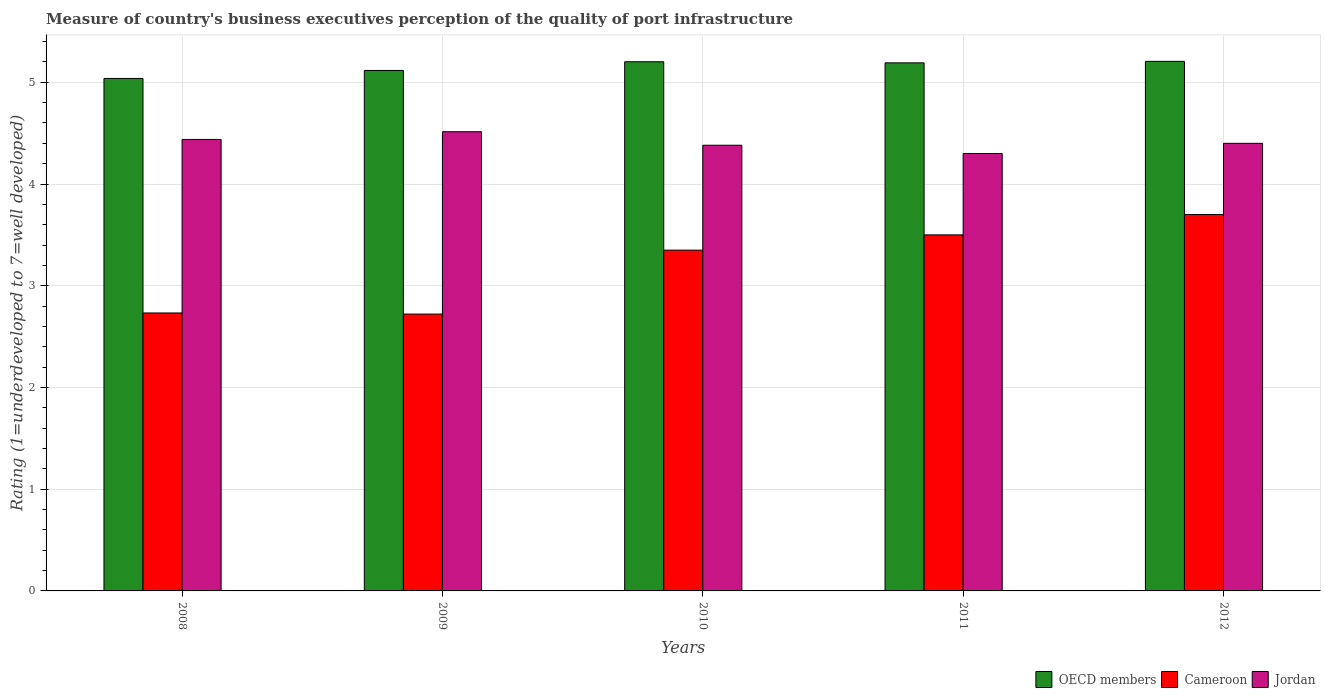How many different coloured bars are there?
Give a very brief answer. 3. Are the number of bars per tick equal to the number of legend labels?
Your answer should be very brief. Yes. What is the label of the 3rd group of bars from the left?
Your response must be concise. 2010. In how many cases, is the number of bars for a given year not equal to the number of legend labels?
Make the answer very short. 0. Across all years, what is the maximum ratings of the quality of port infrastructure in Jordan?
Keep it short and to the point. 4.51. Across all years, what is the minimum ratings of the quality of port infrastructure in Cameroon?
Ensure brevity in your answer.  2.72. In which year was the ratings of the quality of port infrastructure in Cameroon maximum?
Provide a short and direct response. 2012. What is the total ratings of the quality of port infrastructure in Jordan in the graph?
Make the answer very short. 22.03. What is the difference between the ratings of the quality of port infrastructure in Cameroon in 2009 and that in 2012?
Your response must be concise. -0.98. What is the difference between the ratings of the quality of port infrastructure in OECD members in 2008 and the ratings of the quality of port infrastructure in Cameroon in 2012?
Your answer should be very brief. 1.34. What is the average ratings of the quality of port infrastructure in Cameroon per year?
Provide a short and direct response. 3.2. In the year 2008, what is the difference between the ratings of the quality of port infrastructure in Cameroon and ratings of the quality of port infrastructure in OECD members?
Your answer should be very brief. -2.31. What is the ratio of the ratings of the quality of port infrastructure in Jordan in 2008 to that in 2009?
Ensure brevity in your answer.  0.98. What is the difference between the highest and the second highest ratings of the quality of port infrastructure in OECD members?
Keep it short and to the point. 0. What is the difference between the highest and the lowest ratings of the quality of port infrastructure in Jordan?
Your response must be concise. 0.21. In how many years, is the ratings of the quality of port infrastructure in Cameroon greater than the average ratings of the quality of port infrastructure in Cameroon taken over all years?
Offer a terse response. 3. Is the sum of the ratings of the quality of port infrastructure in Cameroon in 2010 and 2011 greater than the maximum ratings of the quality of port infrastructure in Jordan across all years?
Your answer should be compact. Yes. What does the 1st bar from the left in 2008 represents?
Offer a very short reply. OECD members. What does the 1st bar from the right in 2012 represents?
Provide a succinct answer. Jordan. How many bars are there?
Offer a terse response. 15. Are all the bars in the graph horizontal?
Keep it short and to the point. No. How many years are there in the graph?
Your response must be concise. 5. Does the graph contain any zero values?
Provide a succinct answer. No. Does the graph contain grids?
Your answer should be compact. Yes. How are the legend labels stacked?
Provide a succinct answer. Horizontal. What is the title of the graph?
Provide a short and direct response. Measure of country's business executives perception of the quality of port infrastructure. What is the label or title of the X-axis?
Offer a terse response. Years. What is the label or title of the Y-axis?
Give a very brief answer. Rating (1=underdeveloped to 7=well developed). What is the Rating (1=underdeveloped to 7=well developed) in OECD members in 2008?
Keep it short and to the point. 5.04. What is the Rating (1=underdeveloped to 7=well developed) in Cameroon in 2008?
Provide a short and direct response. 2.73. What is the Rating (1=underdeveloped to 7=well developed) in Jordan in 2008?
Provide a succinct answer. 4.44. What is the Rating (1=underdeveloped to 7=well developed) in OECD members in 2009?
Provide a succinct answer. 5.12. What is the Rating (1=underdeveloped to 7=well developed) of Cameroon in 2009?
Your answer should be very brief. 2.72. What is the Rating (1=underdeveloped to 7=well developed) of Jordan in 2009?
Ensure brevity in your answer.  4.51. What is the Rating (1=underdeveloped to 7=well developed) of OECD members in 2010?
Your answer should be compact. 5.2. What is the Rating (1=underdeveloped to 7=well developed) of Cameroon in 2010?
Your response must be concise. 3.35. What is the Rating (1=underdeveloped to 7=well developed) of Jordan in 2010?
Your answer should be compact. 4.38. What is the Rating (1=underdeveloped to 7=well developed) of OECD members in 2011?
Provide a succinct answer. 5.19. What is the Rating (1=underdeveloped to 7=well developed) in Cameroon in 2011?
Your answer should be compact. 3.5. What is the Rating (1=underdeveloped to 7=well developed) of Jordan in 2011?
Your answer should be very brief. 4.3. What is the Rating (1=underdeveloped to 7=well developed) of OECD members in 2012?
Keep it short and to the point. 5.21. What is the Rating (1=underdeveloped to 7=well developed) in Cameroon in 2012?
Your response must be concise. 3.7. What is the Rating (1=underdeveloped to 7=well developed) of Jordan in 2012?
Provide a short and direct response. 4.4. Across all years, what is the maximum Rating (1=underdeveloped to 7=well developed) in OECD members?
Your answer should be very brief. 5.21. Across all years, what is the maximum Rating (1=underdeveloped to 7=well developed) of Jordan?
Make the answer very short. 4.51. Across all years, what is the minimum Rating (1=underdeveloped to 7=well developed) of OECD members?
Provide a short and direct response. 5.04. Across all years, what is the minimum Rating (1=underdeveloped to 7=well developed) of Cameroon?
Provide a succinct answer. 2.72. Across all years, what is the minimum Rating (1=underdeveloped to 7=well developed) in Jordan?
Make the answer very short. 4.3. What is the total Rating (1=underdeveloped to 7=well developed) in OECD members in the graph?
Ensure brevity in your answer.  25.75. What is the total Rating (1=underdeveloped to 7=well developed) of Cameroon in the graph?
Give a very brief answer. 16. What is the total Rating (1=underdeveloped to 7=well developed) of Jordan in the graph?
Your answer should be very brief. 22.03. What is the difference between the Rating (1=underdeveloped to 7=well developed) of OECD members in 2008 and that in 2009?
Provide a short and direct response. -0.08. What is the difference between the Rating (1=underdeveloped to 7=well developed) in Cameroon in 2008 and that in 2009?
Offer a terse response. 0.01. What is the difference between the Rating (1=underdeveloped to 7=well developed) in Jordan in 2008 and that in 2009?
Provide a short and direct response. -0.08. What is the difference between the Rating (1=underdeveloped to 7=well developed) in OECD members in 2008 and that in 2010?
Make the answer very short. -0.16. What is the difference between the Rating (1=underdeveloped to 7=well developed) of Cameroon in 2008 and that in 2010?
Your answer should be very brief. -0.62. What is the difference between the Rating (1=underdeveloped to 7=well developed) of Jordan in 2008 and that in 2010?
Offer a terse response. 0.06. What is the difference between the Rating (1=underdeveloped to 7=well developed) of OECD members in 2008 and that in 2011?
Keep it short and to the point. -0.15. What is the difference between the Rating (1=underdeveloped to 7=well developed) in Cameroon in 2008 and that in 2011?
Your response must be concise. -0.77. What is the difference between the Rating (1=underdeveloped to 7=well developed) in Jordan in 2008 and that in 2011?
Offer a terse response. 0.14. What is the difference between the Rating (1=underdeveloped to 7=well developed) of OECD members in 2008 and that in 2012?
Provide a short and direct response. -0.17. What is the difference between the Rating (1=underdeveloped to 7=well developed) of Cameroon in 2008 and that in 2012?
Provide a succinct answer. -0.97. What is the difference between the Rating (1=underdeveloped to 7=well developed) in Jordan in 2008 and that in 2012?
Your response must be concise. 0.04. What is the difference between the Rating (1=underdeveloped to 7=well developed) of OECD members in 2009 and that in 2010?
Your response must be concise. -0.09. What is the difference between the Rating (1=underdeveloped to 7=well developed) of Cameroon in 2009 and that in 2010?
Keep it short and to the point. -0.63. What is the difference between the Rating (1=underdeveloped to 7=well developed) in Jordan in 2009 and that in 2010?
Your response must be concise. 0.13. What is the difference between the Rating (1=underdeveloped to 7=well developed) in OECD members in 2009 and that in 2011?
Your answer should be very brief. -0.07. What is the difference between the Rating (1=underdeveloped to 7=well developed) in Cameroon in 2009 and that in 2011?
Provide a succinct answer. -0.78. What is the difference between the Rating (1=underdeveloped to 7=well developed) in Jordan in 2009 and that in 2011?
Your answer should be compact. 0.21. What is the difference between the Rating (1=underdeveloped to 7=well developed) of OECD members in 2009 and that in 2012?
Offer a terse response. -0.09. What is the difference between the Rating (1=underdeveloped to 7=well developed) of Cameroon in 2009 and that in 2012?
Your answer should be very brief. -0.98. What is the difference between the Rating (1=underdeveloped to 7=well developed) in Jordan in 2009 and that in 2012?
Offer a very short reply. 0.11. What is the difference between the Rating (1=underdeveloped to 7=well developed) in OECD members in 2010 and that in 2011?
Offer a very short reply. 0.01. What is the difference between the Rating (1=underdeveloped to 7=well developed) of Jordan in 2010 and that in 2011?
Provide a short and direct response. 0.08. What is the difference between the Rating (1=underdeveloped to 7=well developed) of OECD members in 2010 and that in 2012?
Offer a terse response. -0. What is the difference between the Rating (1=underdeveloped to 7=well developed) in Cameroon in 2010 and that in 2012?
Keep it short and to the point. -0.35. What is the difference between the Rating (1=underdeveloped to 7=well developed) in Jordan in 2010 and that in 2012?
Offer a very short reply. -0.02. What is the difference between the Rating (1=underdeveloped to 7=well developed) of OECD members in 2011 and that in 2012?
Provide a succinct answer. -0.01. What is the difference between the Rating (1=underdeveloped to 7=well developed) in Cameroon in 2011 and that in 2012?
Make the answer very short. -0.2. What is the difference between the Rating (1=underdeveloped to 7=well developed) of OECD members in 2008 and the Rating (1=underdeveloped to 7=well developed) of Cameroon in 2009?
Your response must be concise. 2.32. What is the difference between the Rating (1=underdeveloped to 7=well developed) of OECD members in 2008 and the Rating (1=underdeveloped to 7=well developed) of Jordan in 2009?
Offer a very short reply. 0.52. What is the difference between the Rating (1=underdeveloped to 7=well developed) in Cameroon in 2008 and the Rating (1=underdeveloped to 7=well developed) in Jordan in 2009?
Your response must be concise. -1.78. What is the difference between the Rating (1=underdeveloped to 7=well developed) in OECD members in 2008 and the Rating (1=underdeveloped to 7=well developed) in Cameroon in 2010?
Ensure brevity in your answer.  1.69. What is the difference between the Rating (1=underdeveloped to 7=well developed) of OECD members in 2008 and the Rating (1=underdeveloped to 7=well developed) of Jordan in 2010?
Offer a terse response. 0.66. What is the difference between the Rating (1=underdeveloped to 7=well developed) of Cameroon in 2008 and the Rating (1=underdeveloped to 7=well developed) of Jordan in 2010?
Offer a very short reply. -1.65. What is the difference between the Rating (1=underdeveloped to 7=well developed) in OECD members in 2008 and the Rating (1=underdeveloped to 7=well developed) in Cameroon in 2011?
Provide a succinct answer. 1.54. What is the difference between the Rating (1=underdeveloped to 7=well developed) of OECD members in 2008 and the Rating (1=underdeveloped to 7=well developed) of Jordan in 2011?
Your answer should be very brief. 0.74. What is the difference between the Rating (1=underdeveloped to 7=well developed) in Cameroon in 2008 and the Rating (1=underdeveloped to 7=well developed) in Jordan in 2011?
Offer a terse response. -1.57. What is the difference between the Rating (1=underdeveloped to 7=well developed) of OECD members in 2008 and the Rating (1=underdeveloped to 7=well developed) of Cameroon in 2012?
Offer a terse response. 1.34. What is the difference between the Rating (1=underdeveloped to 7=well developed) of OECD members in 2008 and the Rating (1=underdeveloped to 7=well developed) of Jordan in 2012?
Your answer should be very brief. 0.64. What is the difference between the Rating (1=underdeveloped to 7=well developed) in Cameroon in 2008 and the Rating (1=underdeveloped to 7=well developed) in Jordan in 2012?
Your response must be concise. -1.67. What is the difference between the Rating (1=underdeveloped to 7=well developed) of OECD members in 2009 and the Rating (1=underdeveloped to 7=well developed) of Cameroon in 2010?
Give a very brief answer. 1.77. What is the difference between the Rating (1=underdeveloped to 7=well developed) in OECD members in 2009 and the Rating (1=underdeveloped to 7=well developed) in Jordan in 2010?
Your response must be concise. 0.74. What is the difference between the Rating (1=underdeveloped to 7=well developed) in Cameroon in 2009 and the Rating (1=underdeveloped to 7=well developed) in Jordan in 2010?
Give a very brief answer. -1.66. What is the difference between the Rating (1=underdeveloped to 7=well developed) of OECD members in 2009 and the Rating (1=underdeveloped to 7=well developed) of Cameroon in 2011?
Offer a very short reply. 1.62. What is the difference between the Rating (1=underdeveloped to 7=well developed) in OECD members in 2009 and the Rating (1=underdeveloped to 7=well developed) in Jordan in 2011?
Ensure brevity in your answer.  0.82. What is the difference between the Rating (1=underdeveloped to 7=well developed) of Cameroon in 2009 and the Rating (1=underdeveloped to 7=well developed) of Jordan in 2011?
Keep it short and to the point. -1.58. What is the difference between the Rating (1=underdeveloped to 7=well developed) in OECD members in 2009 and the Rating (1=underdeveloped to 7=well developed) in Cameroon in 2012?
Give a very brief answer. 1.42. What is the difference between the Rating (1=underdeveloped to 7=well developed) in OECD members in 2009 and the Rating (1=underdeveloped to 7=well developed) in Jordan in 2012?
Offer a terse response. 0.72. What is the difference between the Rating (1=underdeveloped to 7=well developed) of Cameroon in 2009 and the Rating (1=underdeveloped to 7=well developed) of Jordan in 2012?
Offer a terse response. -1.68. What is the difference between the Rating (1=underdeveloped to 7=well developed) in OECD members in 2010 and the Rating (1=underdeveloped to 7=well developed) in Cameroon in 2011?
Offer a very short reply. 1.7. What is the difference between the Rating (1=underdeveloped to 7=well developed) of OECD members in 2010 and the Rating (1=underdeveloped to 7=well developed) of Jordan in 2011?
Ensure brevity in your answer.  0.9. What is the difference between the Rating (1=underdeveloped to 7=well developed) of Cameroon in 2010 and the Rating (1=underdeveloped to 7=well developed) of Jordan in 2011?
Your answer should be very brief. -0.95. What is the difference between the Rating (1=underdeveloped to 7=well developed) of OECD members in 2010 and the Rating (1=underdeveloped to 7=well developed) of Cameroon in 2012?
Offer a terse response. 1.5. What is the difference between the Rating (1=underdeveloped to 7=well developed) of OECD members in 2010 and the Rating (1=underdeveloped to 7=well developed) of Jordan in 2012?
Provide a succinct answer. 0.8. What is the difference between the Rating (1=underdeveloped to 7=well developed) in Cameroon in 2010 and the Rating (1=underdeveloped to 7=well developed) in Jordan in 2012?
Offer a very short reply. -1.05. What is the difference between the Rating (1=underdeveloped to 7=well developed) of OECD members in 2011 and the Rating (1=underdeveloped to 7=well developed) of Cameroon in 2012?
Provide a short and direct response. 1.49. What is the difference between the Rating (1=underdeveloped to 7=well developed) in OECD members in 2011 and the Rating (1=underdeveloped to 7=well developed) in Jordan in 2012?
Your answer should be compact. 0.79. What is the average Rating (1=underdeveloped to 7=well developed) in OECD members per year?
Ensure brevity in your answer.  5.15. What is the average Rating (1=underdeveloped to 7=well developed) of Cameroon per year?
Provide a succinct answer. 3.2. What is the average Rating (1=underdeveloped to 7=well developed) of Jordan per year?
Provide a succinct answer. 4.41. In the year 2008, what is the difference between the Rating (1=underdeveloped to 7=well developed) of OECD members and Rating (1=underdeveloped to 7=well developed) of Cameroon?
Make the answer very short. 2.31. In the year 2008, what is the difference between the Rating (1=underdeveloped to 7=well developed) of OECD members and Rating (1=underdeveloped to 7=well developed) of Jordan?
Make the answer very short. 0.6. In the year 2008, what is the difference between the Rating (1=underdeveloped to 7=well developed) of Cameroon and Rating (1=underdeveloped to 7=well developed) of Jordan?
Ensure brevity in your answer.  -1.71. In the year 2009, what is the difference between the Rating (1=underdeveloped to 7=well developed) of OECD members and Rating (1=underdeveloped to 7=well developed) of Cameroon?
Offer a very short reply. 2.39. In the year 2009, what is the difference between the Rating (1=underdeveloped to 7=well developed) in OECD members and Rating (1=underdeveloped to 7=well developed) in Jordan?
Your response must be concise. 0.6. In the year 2009, what is the difference between the Rating (1=underdeveloped to 7=well developed) in Cameroon and Rating (1=underdeveloped to 7=well developed) in Jordan?
Provide a succinct answer. -1.79. In the year 2010, what is the difference between the Rating (1=underdeveloped to 7=well developed) of OECD members and Rating (1=underdeveloped to 7=well developed) of Cameroon?
Your answer should be compact. 1.85. In the year 2010, what is the difference between the Rating (1=underdeveloped to 7=well developed) of OECD members and Rating (1=underdeveloped to 7=well developed) of Jordan?
Your response must be concise. 0.82. In the year 2010, what is the difference between the Rating (1=underdeveloped to 7=well developed) of Cameroon and Rating (1=underdeveloped to 7=well developed) of Jordan?
Keep it short and to the point. -1.03. In the year 2011, what is the difference between the Rating (1=underdeveloped to 7=well developed) in OECD members and Rating (1=underdeveloped to 7=well developed) in Cameroon?
Give a very brief answer. 1.69. In the year 2011, what is the difference between the Rating (1=underdeveloped to 7=well developed) of OECD members and Rating (1=underdeveloped to 7=well developed) of Jordan?
Your answer should be compact. 0.89. In the year 2012, what is the difference between the Rating (1=underdeveloped to 7=well developed) of OECD members and Rating (1=underdeveloped to 7=well developed) of Cameroon?
Offer a terse response. 1.51. In the year 2012, what is the difference between the Rating (1=underdeveloped to 7=well developed) of OECD members and Rating (1=underdeveloped to 7=well developed) of Jordan?
Give a very brief answer. 0.81. What is the ratio of the Rating (1=underdeveloped to 7=well developed) in OECD members in 2008 to that in 2009?
Offer a terse response. 0.98. What is the ratio of the Rating (1=underdeveloped to 7=well developed) of Jordan in 2008 to that in 2009?
Your answer should be very brief. 0.98. What is the ratio of the Rating (1=underdeveloped to 7=well developed) in OECD members in 2008 to that in 2010?
Provide a succinct answer. 0.97. What is the ratio of the Rating (1=underdeveloped to 7=well developed) in Cameroon in 2008 to that in 2010?
Offer a very short reply. 0.82. What is the ratio of the Rating (1=underdeveloped to 7=well developed) of Jordan in 2008 to that in 2010?
Offer a very short reply. 1.01. What is the ratio of the Rating (1=underdeveloped to 7=well developed) in OECD members in 2008 to that in 2011?
Provide a short and direct response. 0.97. What is the ratio of the Rating (1=underdeveloped to 7=well developed) of Cameroon in 2008 to that in 2011?
Your answer should be very brief. 0.78. What is the ratio of the Rating (1=underdeveloped to 7=well developed) of Jordan in 2008 to that in 2011?
Your response must be concise. 1.03. What is the ratio of the Rating (1=underdeveloped to 7=well developed) in OECD members in 2008 to that in 2012?
Provide a succinct answer. 0.97. What is the ratio of the Rating (1=underdeveloped to 7=well developed) of Cameroon in 2008 to that in 2012?
Provide a succinct answer. 0.74. What is the ratio of the Rating (1=underdeveloped to 7=well developed) in Jordan in 2008 to that in 2012?
Make the answer very short. 1.01. What is the ratio of the Rating (1=underdeveloped to 7=well developed) of OECD members in 2009 to that in 2010?
Keep it short and to the point. 0.98. What is the ratio of the Rating (1=underdeveloped to 7=well developed) of Cameroon in 2009 to that in 2010?
Provide a short and direct response. 0.81. What is the ratio of the Rating (1=underdeveloped to 7=well developed) of Jordan in 2009 to that in 2010?
Ensure brevity in your answer.  1.03. What is the ratio of the Rating (1=underdeveloped to 7=well developed) in OECD members in 2009 to that in 2011?
Provide a succinct answer. 0.99. What is the ratio of the Rating (1=underdeveloped to 7=well developed) in Cameroon in 2009 to that in 2011?
Provide a succinct answer. 0.78. What is the ratio of the Rating (1=underdeveloped to 7=well developed) of Jordan in 2009 to that in 2011?
Offer a very short reply. 1.05. What is the ratio of the Rating (1=underdeveloped to 7=well developed) in OECD members in 2009 to that in 2012?
Your answer should be compact. 0.98. What is the ratio of the Rating (1=underdeveloped to 7=well developed) in Cameroon in 2009 to that in 2012?
Give a very brief answer. 0.74. What is the ratio of the Rating (1=underdeveloped to 7=well developed) in Jordan in 2009 to that in 2012?
Your response must be concise. 1.03. What is the ratio of the Rating (1=underdeveloped to 7=well developed) in OECD members in 2010 to that in 2011?
Provide a succinct answer. 1. What is the ratio of the Rating (1=underdeveloped to 7=well developed) in Cameroon in 2010 to that in 2011?
Your response must be concise. 0.96. What is the ratio of the Rating (1=underdeveloped to 7=well developed) of Jordan in 2010 to that in 2011?
Make the answer very short. 1.02. What is the ratio of the Rating (1=underdeveloped to 7=well developed) in Cameroon in 2010 to that in 2012?
Your response must be concise. 0.91. What is the ratio of the Rating (1=underdeveloped to 7=well developed) of Jordan in 2010 to that in 2012?
Your answer should be very brief. 1. What is the ratio of the Rating (1=underdeveloped to 7=well developed) in Cameroon in 2011 to that in 2012?
Offer a terse response. 0.95. What is the ratio of the Rating (1=underdeveloped to 7=well developed) of Jordan in 2011 to that in 2012?
Your answer should be compact. 0.98. What is the difference between the highest and the second highest Rating (1=underdeveloped to 7=well developed) in OECD members?
Offer a terse response. 0. What is the difference between the highest and the second highest Rating (1=underdeveloped to 7=well developed) in Cameroon?
Provide a succinct answer. 0.2. What is the difference between the highest and the second highest Rating (1=underdeveloped to 7=well developed) in Jordan?
Make the answer very short. 0.08. What is the difference between the highest and the lowest Rating (1=underdeveloped to 7=well developed) of OECD members?
Ensure brevity in your answer.  0.17. What is the difference between the highest and the lowest Rating (1=underdeveloped to 7=well developed) in Cameroon?
Make the answer very short. 0.98. What is the difference between the highest and the lowest Rating (1=underdeveloped to 7=well developed) in Jordan?
Give a very brief answer. 0.21. 